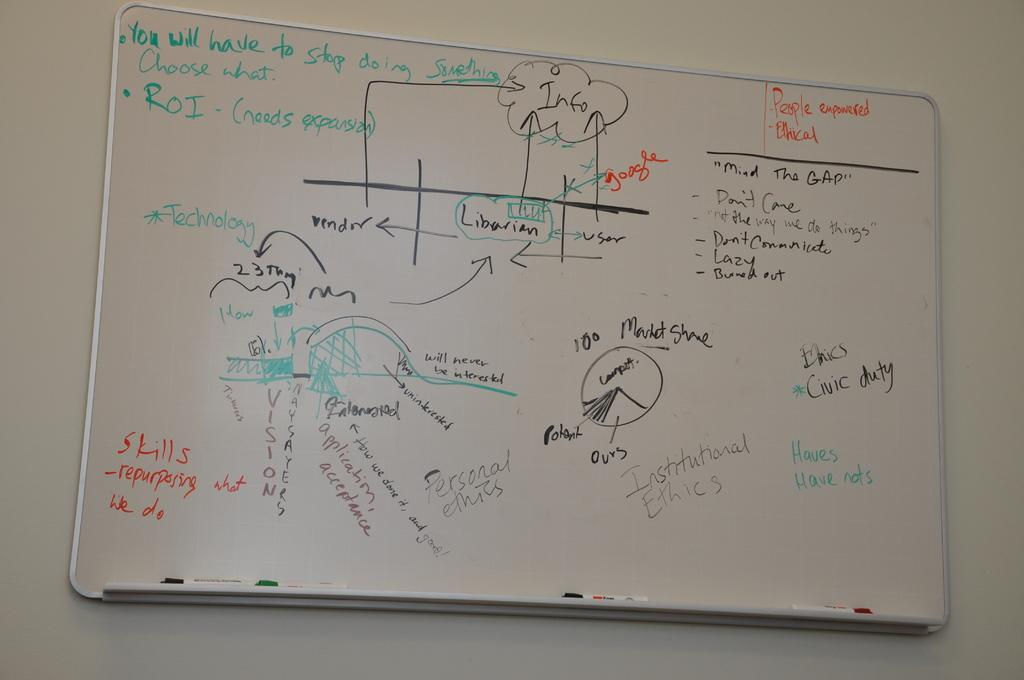<image>
Offer a succinct explanation of the picture presented. A whiteboard with much writing has People empowered and Ethical in orange in the corner. 